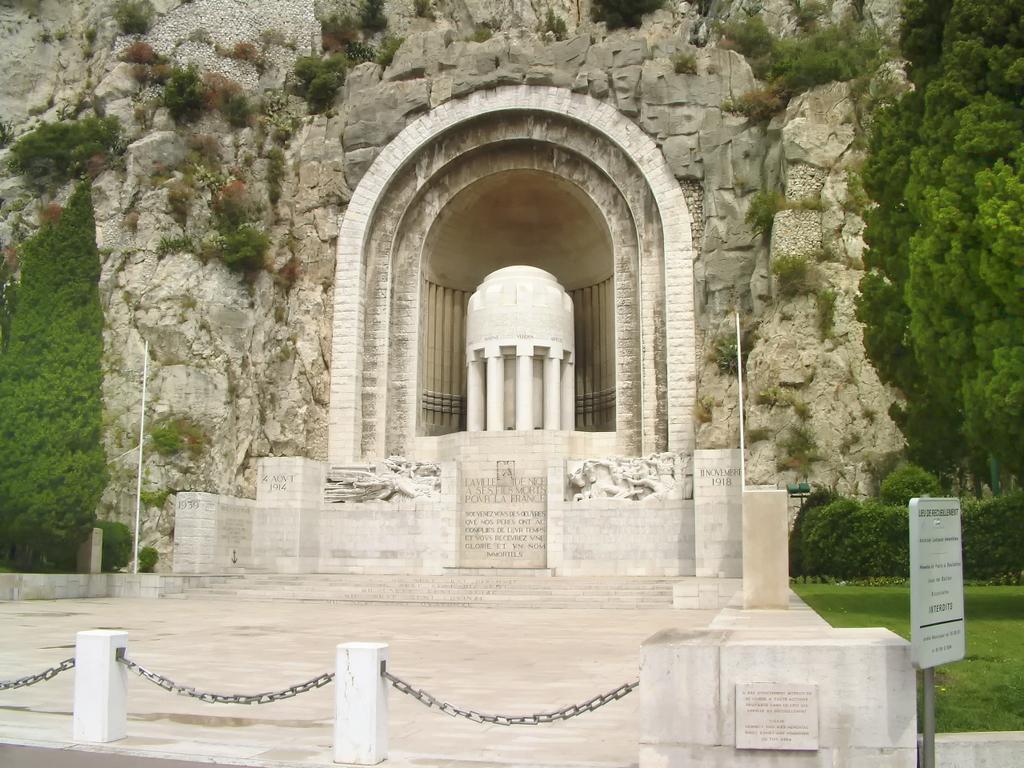Describe this image in one or two sentences. This is a fort and in the background, there are trees, bushes, stairs, poles and we can see a fence and a board. At the bottom, there is ground. 